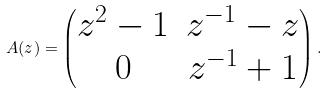<formula> <loc_0><loc_0><loc_500><loc_500>A ( z ) = \begin{pmatrix} z ^ { 2 } - 1 & z ^ { - 1 } - z \\ 0 & z ^ { - 1 } + 1 \end{pmatrix} .</formula> 